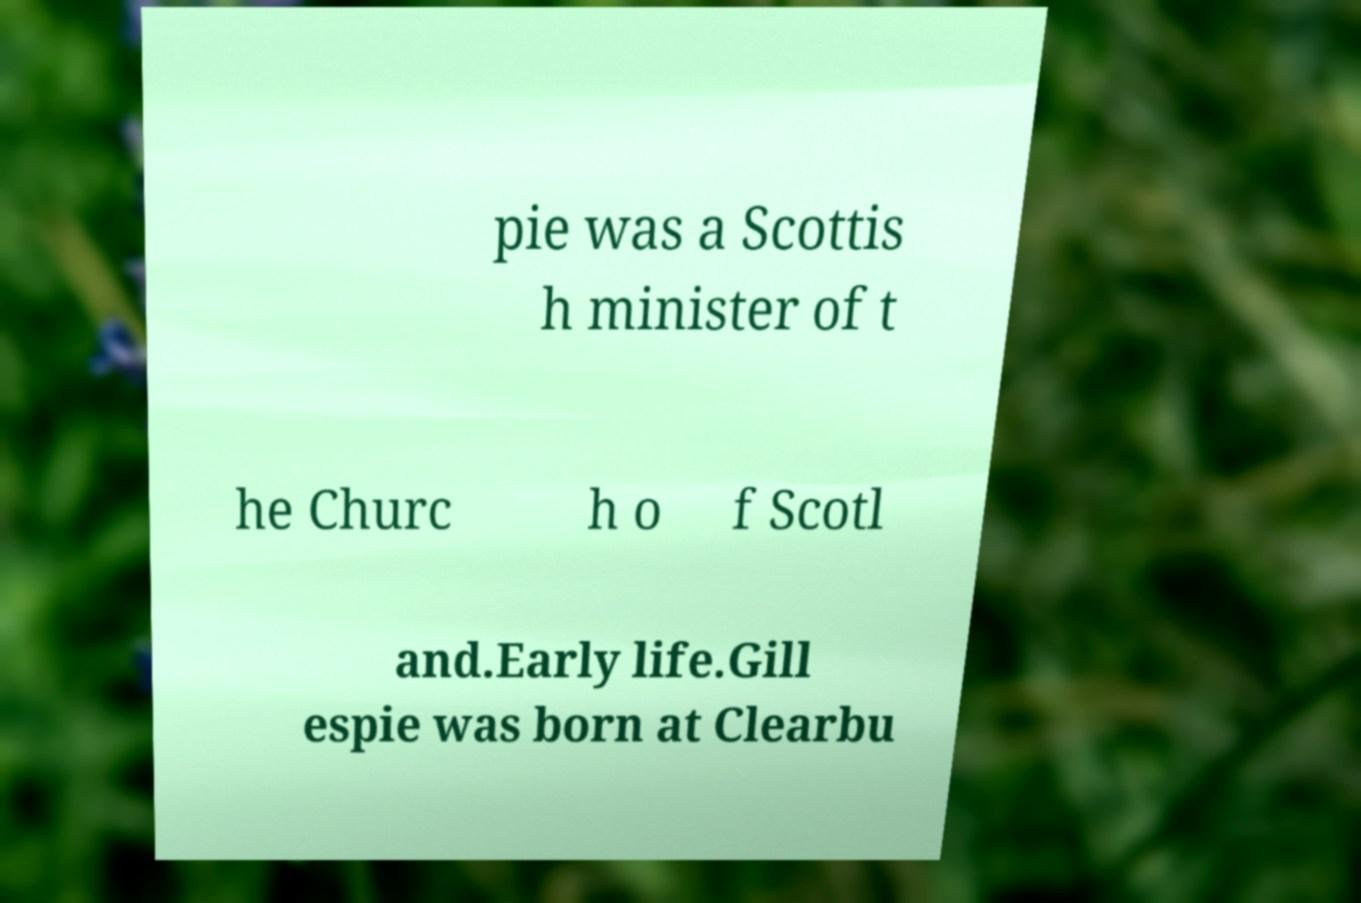Could you extract and type out the text from this image? pie was a Scottis h minister of t he Churc h o f Scotl and.Early life.Gill espie was born at Clearbu 